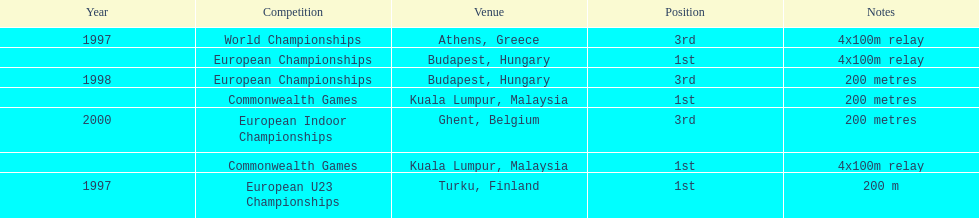In what year did england get the top achievment in the 200 meter? 1997. 